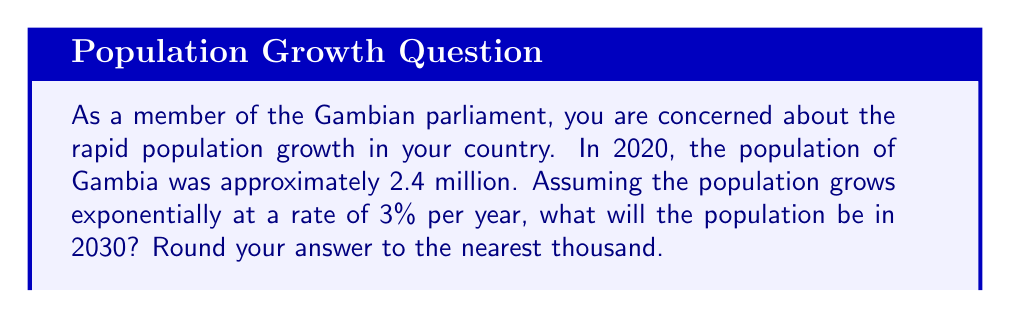Help me with this question. To solve this problem, we'll use the exponential growth model:

$$P(t) = P_0 \cdot e^{rt}$$

Where:
$P(t)$ is the population at time $t$
$P_0$ is the initial population
$e$ is Euler's number (approximately 2.71828)
$r$ is the growth rate (as a decimal)
$t$ is the time in years

Given:
$P_0 = 2,400,000$ (initial population in 2020)
$r = 0.03$ (3% annual growth rate)
$t = 10$ (years from 2020 to 2030)

Let's substitute these values into the equation:

$$P(10) = 2,400,000 \cdot e^{0.03 \cdot 10}$$

Simplify the exponent:
$$P(10) = 2,400,000 \cdot e^{0.3}$$

Using a calculator or computer to evaluate $e^{0.3}$:
$$P(10) = 2,400,000 \cdot 1.34986$$

Multiply:
$$P(10) = 3,239,664$$

Rounding to the nearest thousand:
$$P(10) \approx 3,240,000$$
Answer: The population of Gambia in 2030 will be approximately 3,240,000 people. 